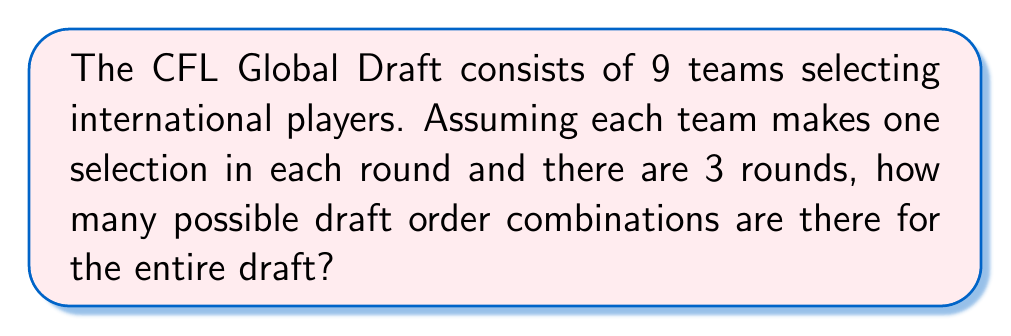Solve this math problem. To solve this problem, we need to consider the number of possible arrangements for each round and then combine them for the entire draft.

1. For the first round:
   There are 9 teams, and they can be arranged in any order.
   Number of possibilities = $9!$ (9 factorial)

2. For the second round:
   Again, all 9 teams pick, so there are 9! possibilities.

3. For the third round:
   Once more, all 9 teams pick, resulting in 9! possibilities.

4. To get the total number of possible draft order combinations, we multiply the possibilities for each round:

   Total combinations = $9! \times 9! \times 9!$

5. Calculating this:
   $9! = 362,880$
   
   $$(362,880)^3 = 47,784,725,839,872,000$$

This extremely large number demonstrates why predicting draft outcomes can be challenging, potentially explaining the skepticism about the impact of the CFL Global Draft.
Answer: $47,784,725,839,872,000$ 